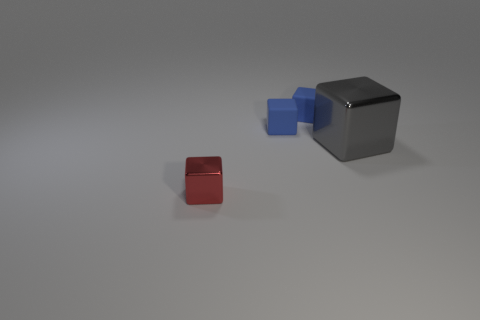Subtract all small red metallic blocks. How many blocks are left? 3 Subtract all blue cubes. Subtract all green cylinders. How many cubes are left? 2 Subtract all gray balls. How many yellow cubes are left? 0 Subtract all matte blocks. Subtract all tiny blue matte things. How many objects are left? 0 Add 2 gray shiny cubes. How many gray shiny cubes are left? 3 Add 2 big gray shiny objects. How many big gray shiny objects exist? 3 Add 4 small matte cubes. How many objects exist? 8 Subtract all gray cubes. How many cubes are left? 3 Subtract 0 gray cylinders. How many objects are left? 4 